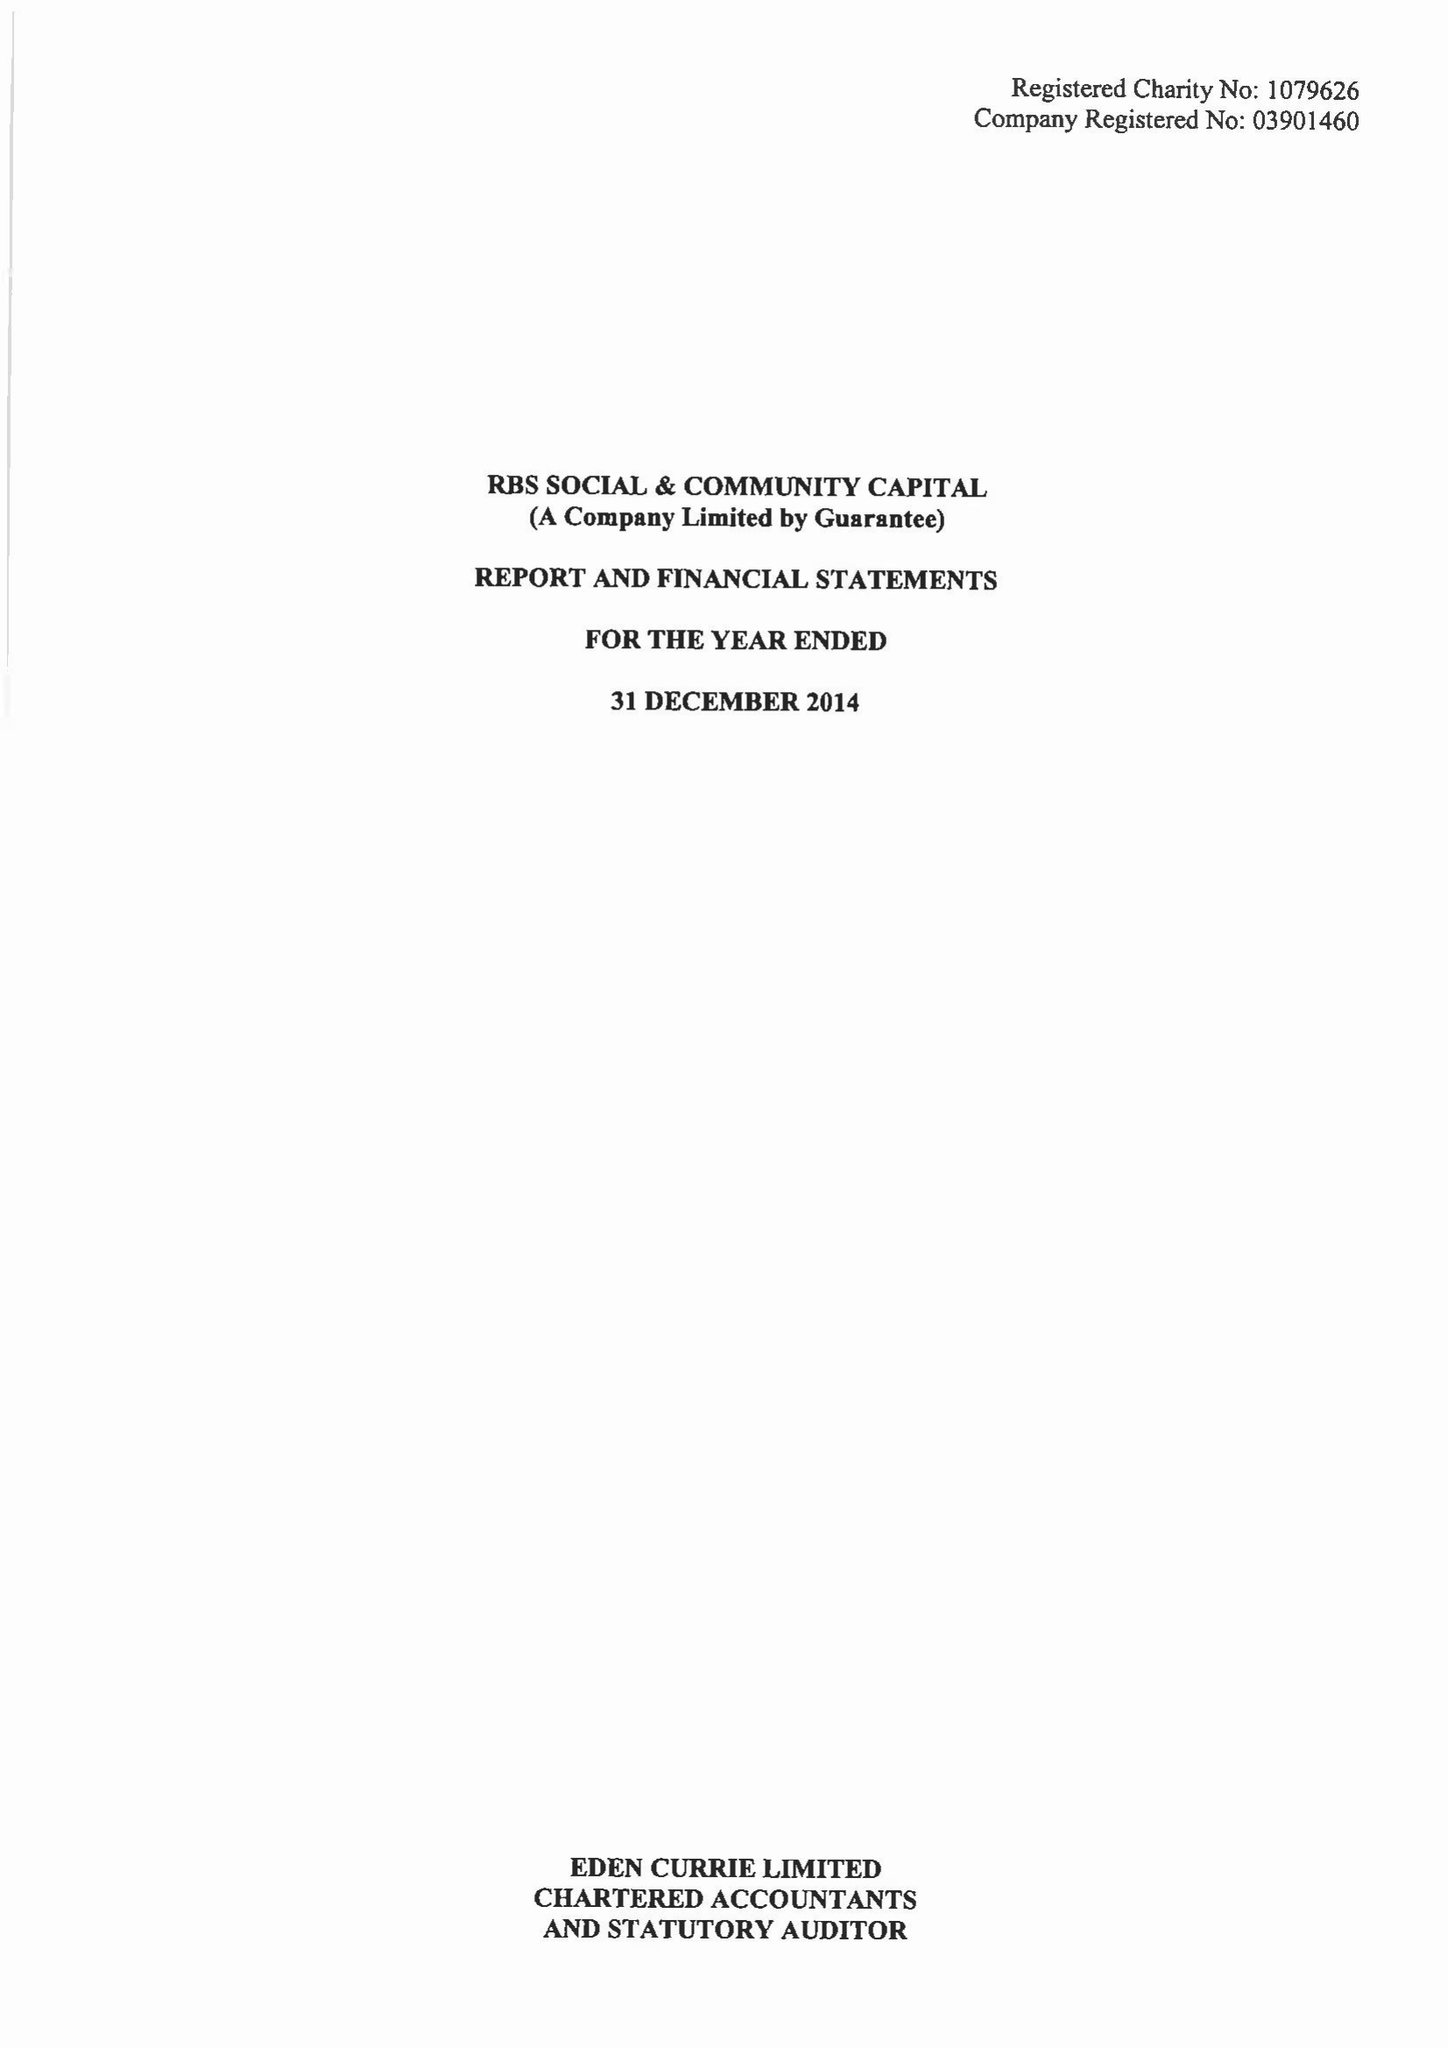What is the value for the charity_number?
Answer the question using a single word or phrase. 1079626 